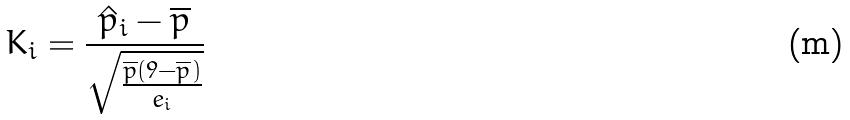<formula> <loc_0><loc_0><loc_500><loc_500>K _ { i } = \frac { \hat { p } _ { i } - \overline { p } } { \sqrt { \frac { \overline { p } ( 9 - \overline { p } ) } { e _ { i } } } }</formula> 